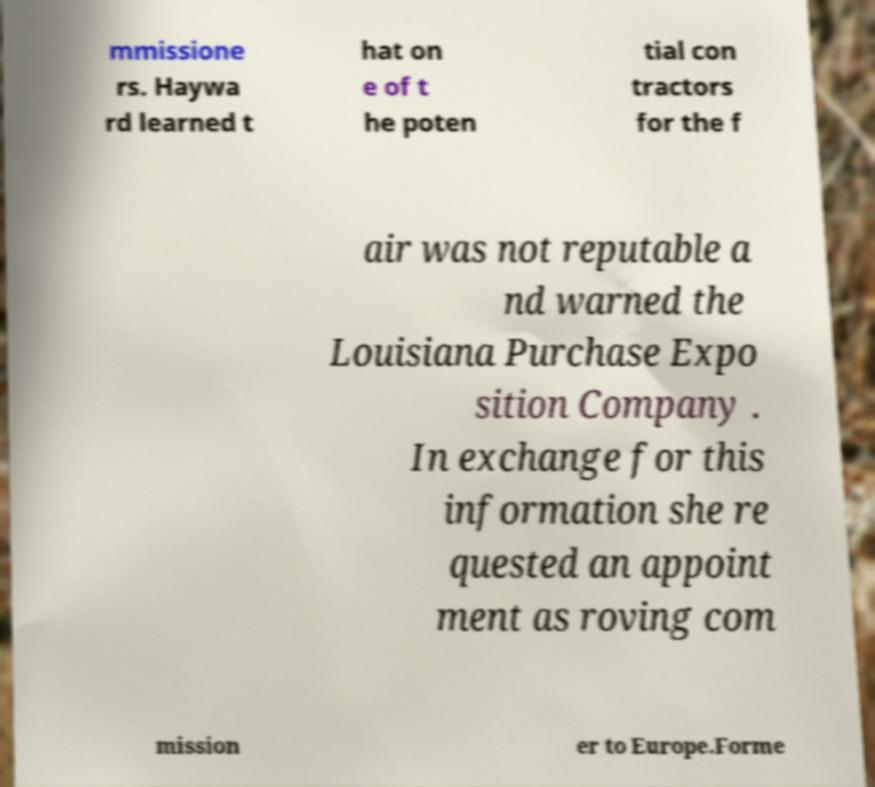Please identify and transcribe the text found in this image. mmissione rs. Haywa rd learned t hat on e of t he poten tial con tractors for the f air was not reputable a nd warned the Louisiana Purchase Expo sition Company . In exchange for this information she re quested an appoint ment as roving com mission er to Europe.Forme 